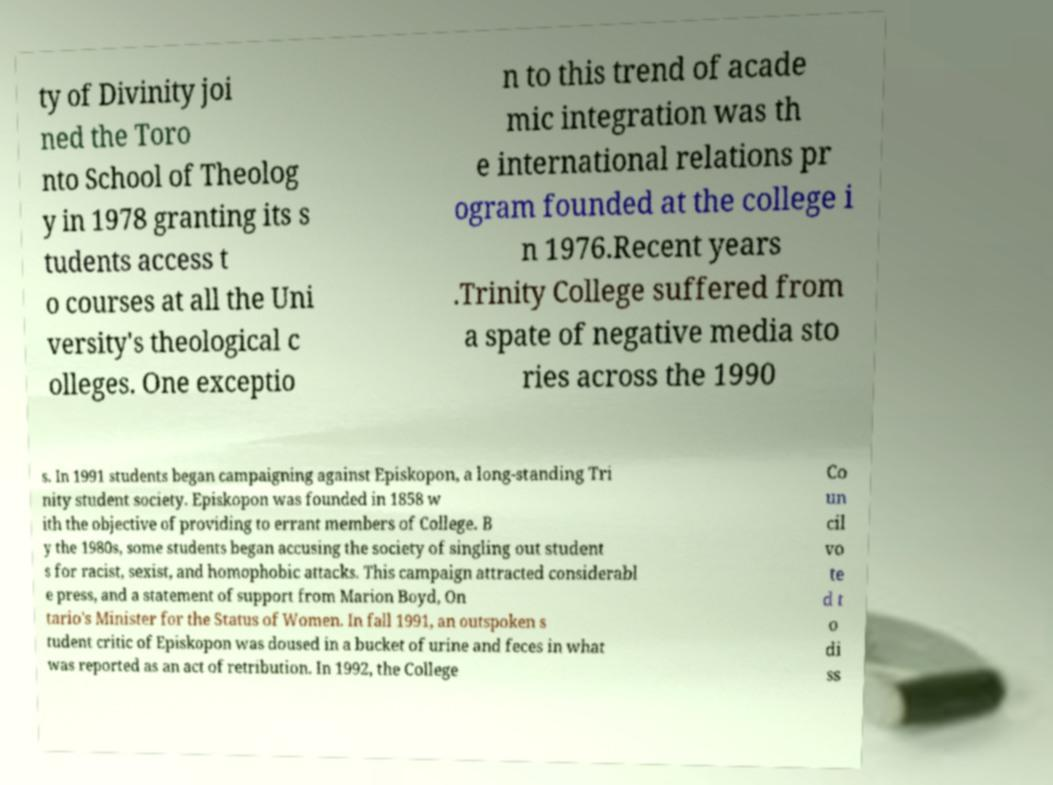For documentation purposes, I need the text within this image transcribed. Could you provide that? ty of Divinity joi ned the Toro nto School of Theolog y in 1978 granting its s tudents access t o courses at all the Uni versity's theological c olleges. One exceptio n to this trend of acade mic integration was th e international relations pr ogram founded at the college i n 1976.Recent years .Trinity College suffered from a spate of negative media sto ries across the 1990 s. In 1991 students began campaigning against Episkopon, a long-standing Tri nity student society. Episkopon was founded in 1858 w ith the objective of providing to errant members of College. B y the 1980s, some students began accusing the society of singling out student s for racist, sexist, and homophobic attacks. This campaign attracted considerabl e press, and a statement of support from Marion Boyd, On tario's Minister for the Status of Women. In fall 1991, an outspoken s tudent critic of Episkopon was doused in a bucket of urine and feces in what was reported as an act of retribution. In 1992, the College Co un cil vo te d t o di ss 